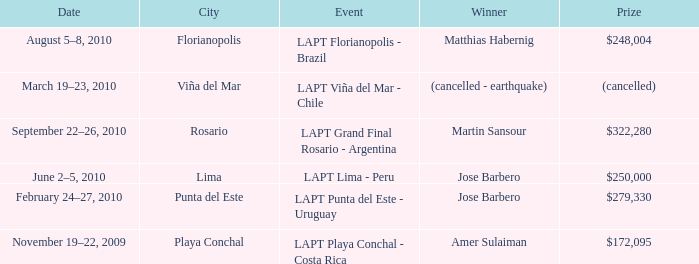When is the event offering a $322,280 reward scheduled? September 22–26, 2010. 